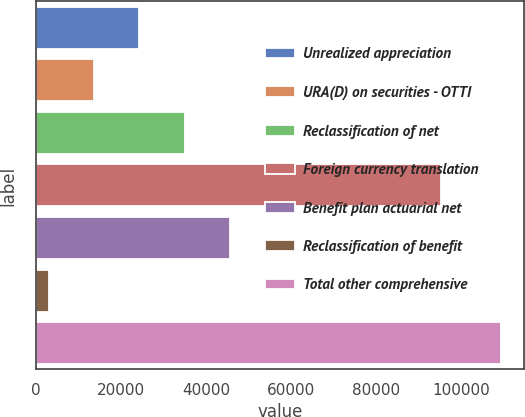Convert chart. <chart><loc_0><loc_0><loc_500><loc_500><bar_chart><fcel>Unrealized appreciation<fcel>URA(D) on securities - OTTI<fcel>Reclassification of net<fcel>Foreign currency translation<fcel>Benefit plan actuarial net<fcel>Reclassification of benefit<fcel>Total other comprehensive<nl><fcel>24298.2<fcel>13659.1<fcel>34937.3<fcel>95417<fcel>45576.4<fcel>3020<fcel>109411<nl></chart> 